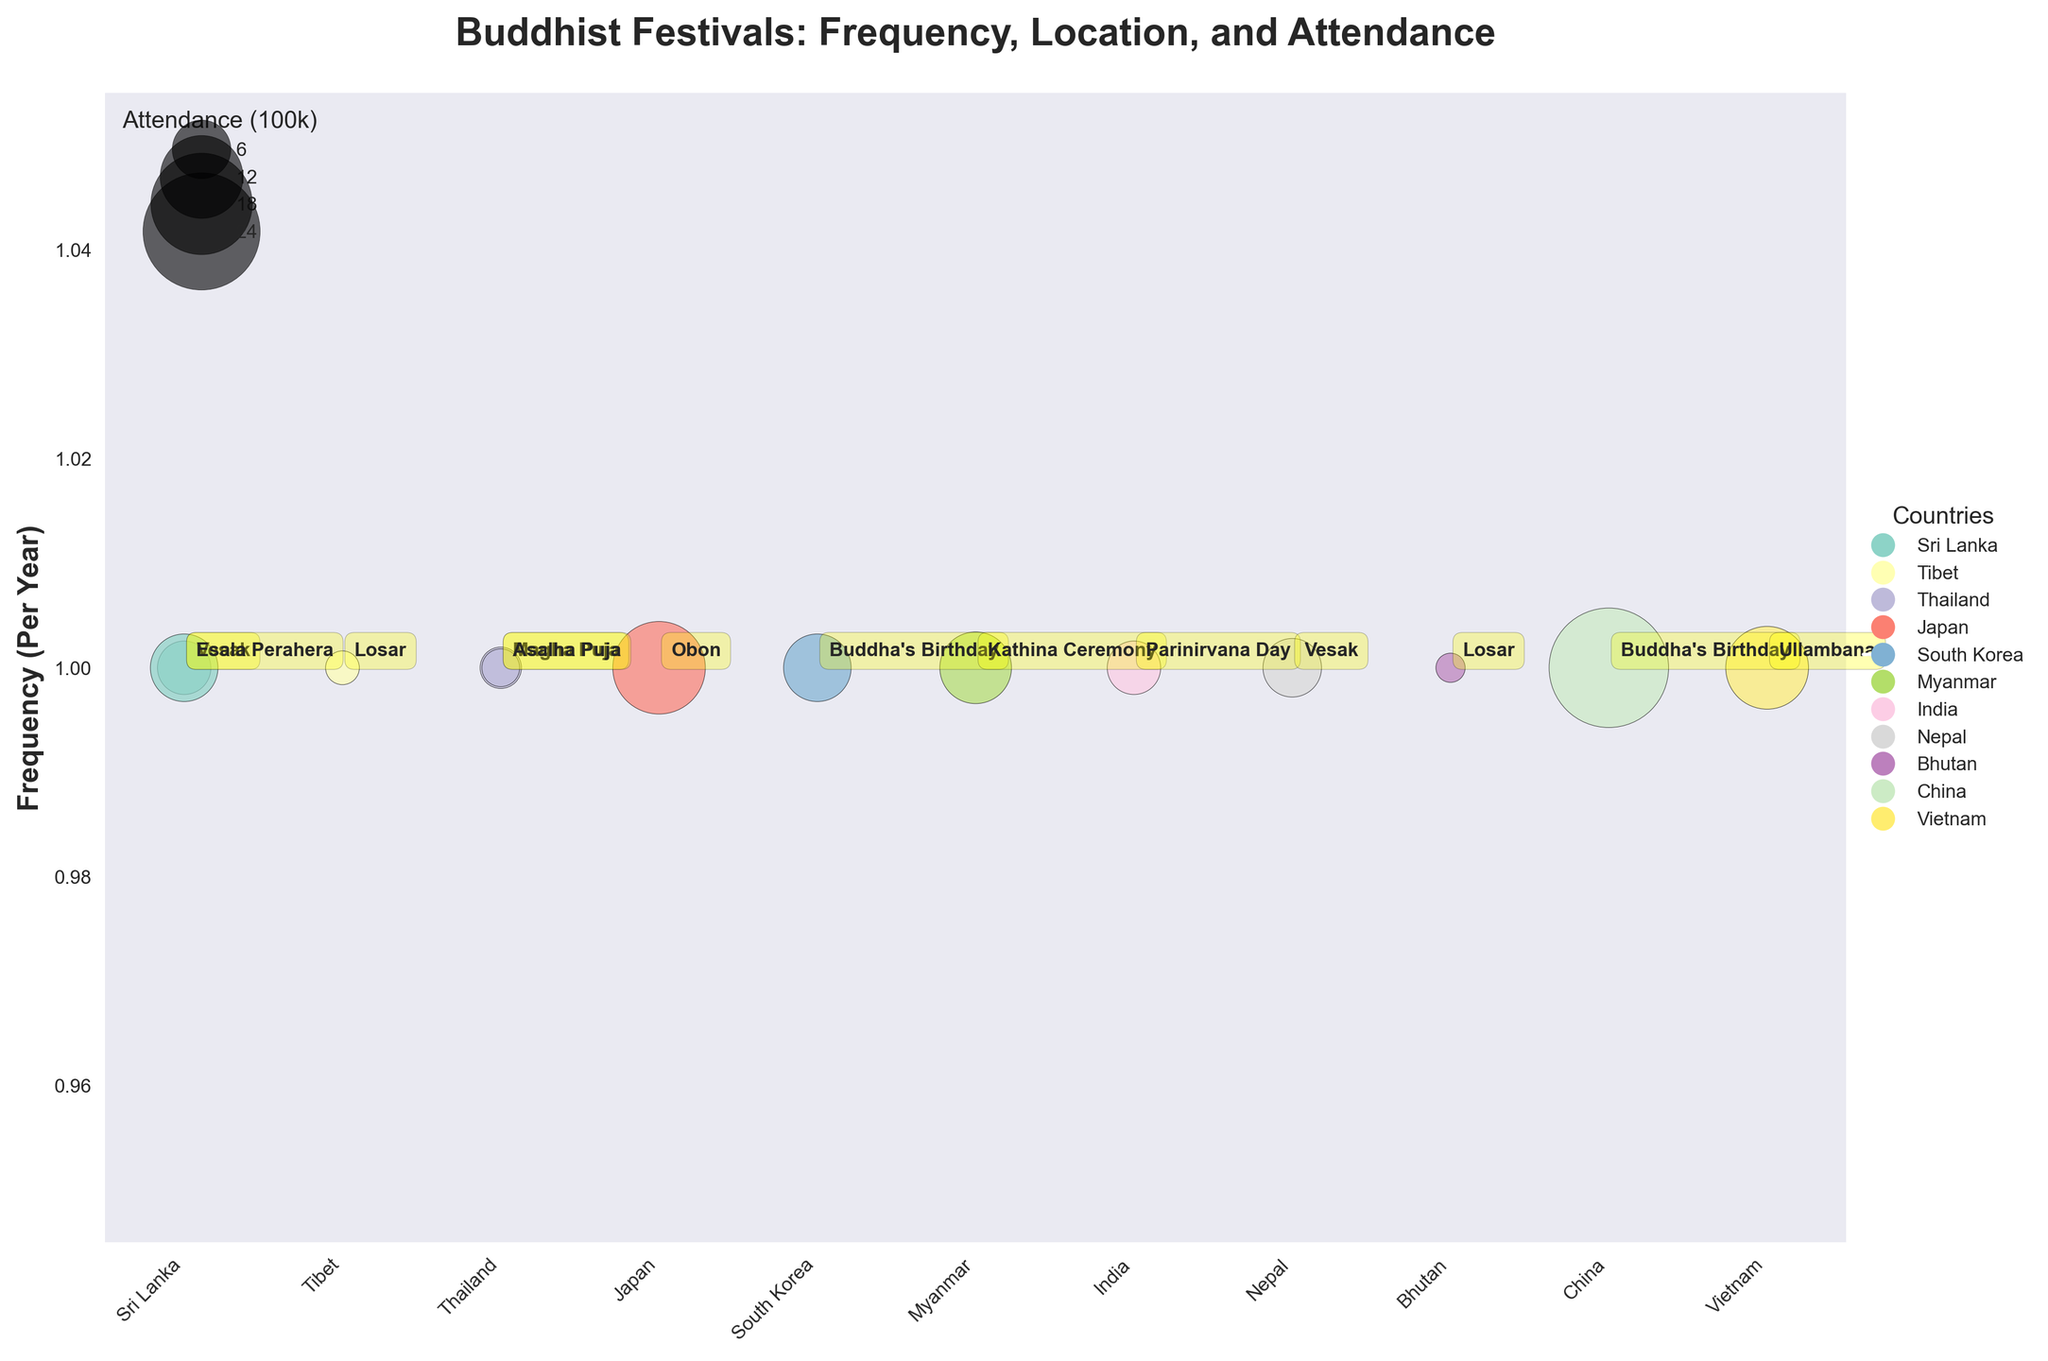Which country has the highest attendance for any single festival? The bubble chart shows the size of the bubbles corresponding to attendance. The largest bubble is for China, indicating the highest attendance.
Answer: China How many countries host Vesak? By visually identifying the annotations for Vesak on the bubble chart, the countries listed are Sri Lanka and Nepal.
Answer: 2 Which festival in Japan has the highest attendance? The only festival in Japan is Obon, as seen in the bubble chart annotation.
Answer: Obon What is the total attendance for Vesak across all countries? The attendance for Vesak in Sri Lanka is 500, and in Nepal, it's 600. Summing them gives 500 + 600 = 1100.
Answer: 1100 Which festival occurs only once per year and has the highest attendance? The plot shows bubble size for attendance; "Buddha's Birthday" in China, with an attendance of 2500, is the largest bubble among festivals that happen once per year.
Answer: Buddha's Birthday (China) Compare the attendance of festivals held in Sri Lanka. Which one has higher attendance? Sri Lanka hosts Vesak and Esala Perahera. Vesak has 500 attendees, while Esala Perahera has 800 attendees. Esala Perahera has higher attendance.
Answer: Esala Perahera What is the most frequently occurring festival per year? All festivals in the dataset occur once per year, as indicated by their frequency (1), making them equal in frequency.
Answer: All are equal Which country hosts the Kathina Ceremony, and what is its attendance? The annotation for Kathina Ceremony on the bubble chart shows that it's held in Myanmar with an attendance of 900.
Answer: Myanmar, 900 What is the average attendance for the festivals in Thailand? Thailand hosts Magha Puja and Asalha Puja. Their attendances are 300 and 250 respectively. The average is (300 + 250) / 2 = 275.
Answer: 275 Is there any country that hosts two different festivals with the same attendance? By examining the data points, no country has two festivals with the same attendance value.
Answer: No 